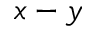Convert formula to latex. <formula><loc_0><loc_0><loc_500><loc_500>x - y</formula> 